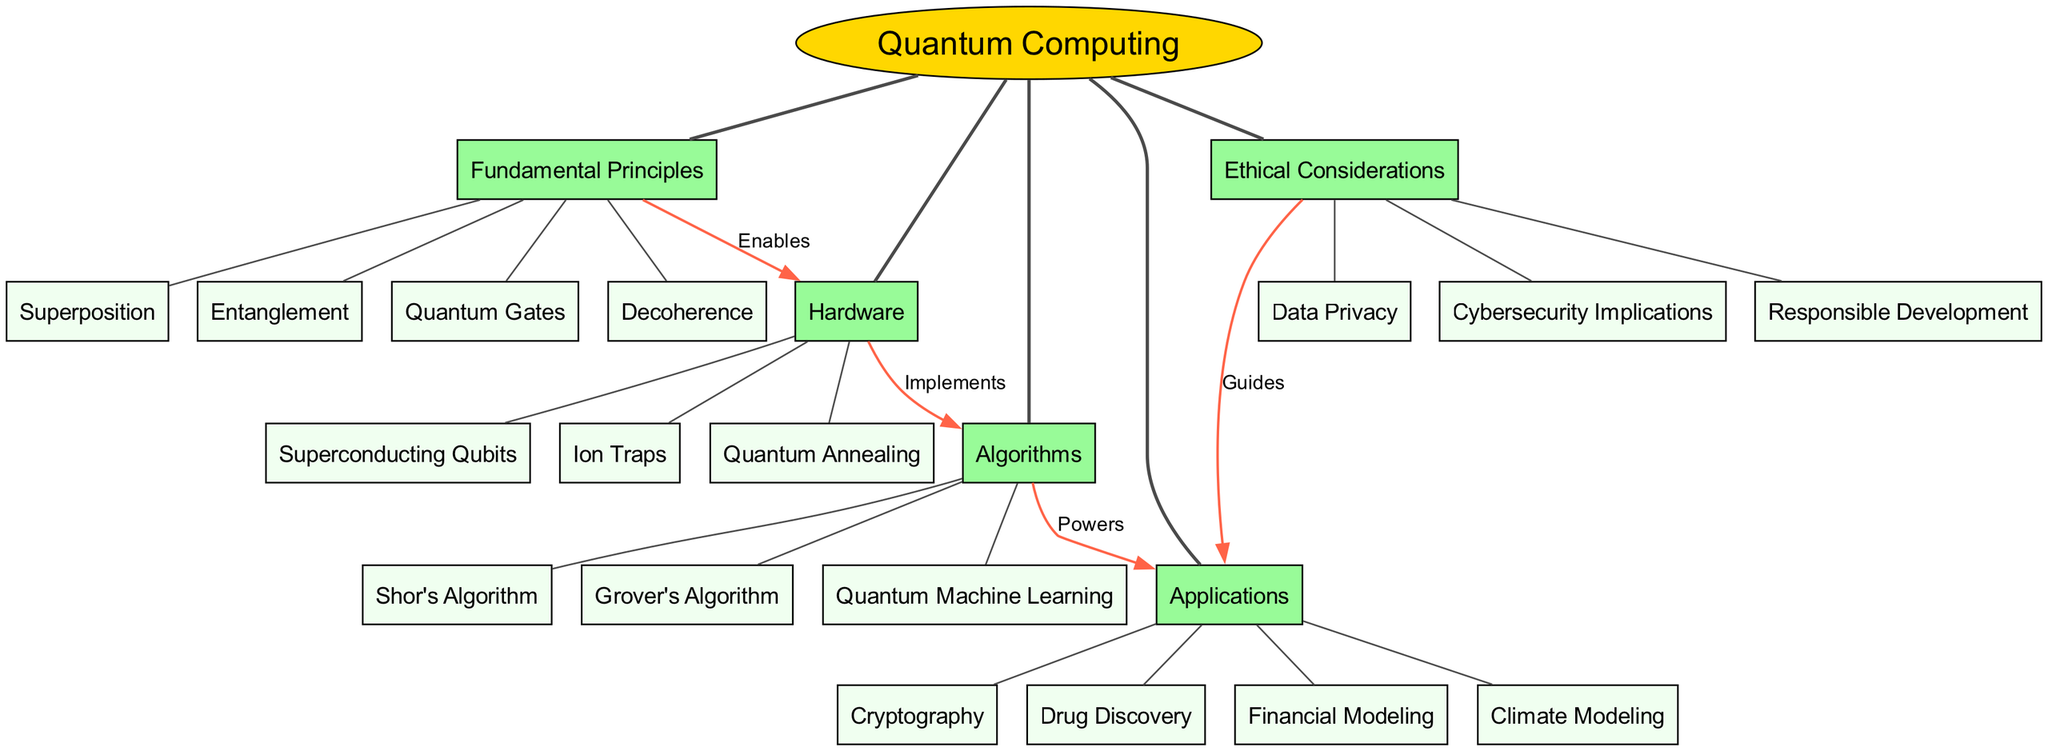What is the central topic of the diagram? The diagram has "Quantum Computing" as the central topic, represented by an ellipse at the center.
Answer: Quantum Computing How many main branches are there in the diagram? The diagram features five main branches that stem from the central topic. By counting these branches, we find the total.
Answer: Five Which hardware component is listed under the "Hardware" branch? The "Hardware" branch includes several subtopics. One of these is "Superconducting Qubits," which can be identified as a specific component within this branch.
Answer: Superconducting Qubits What is the connection label between "Fundamental Principles" and "Hardware"? The connection exists between the "Fundamental Principles" and "Hardware" branches and is labeled with the word "Enables." This label indicates the nature of their relationship.
Answer: Enables Which algorithm is listed as a sub-topic under the "Algorithms" branch? Within the "Algorithms" branch, one of the sub-topics is "Grover's Algorithm." It is recognized as a specific algorithm highlighted in that section of the diagram.
Answer: Grover's Algorithm What guides the relationship between "Ethical Considerations" and "Applications"? The relationship indicated between these two branches is labeled as "Guides." This label signifies that ethical considerations serve as a guiding principle for applications in quantum computing.
Answer: Guides How does "Quantum Gates" relate to "Fundamental Principles"? "Quantum Gates" is a sub-topic listed under the "Fundamental Principles" branch, signifying its inclusion as a core element of the foundational concepts in quantum computing.
Answer: Quantum Gates Which application is associated with the topic of financial modeling? The "Applications" branch includes "Financial Modeling" as one of its specific applications. This can be directly identified from the listed sub-topics under this section.
Answer: Financial Modeling What is the relationship between "Algorithms" and "Applications"? The connection from "Algorithms" to "Applications" is labeled with the term "Powers," indicating that the algorithms enhance or enable the various applications of quantum computing.
Answer: Powers 